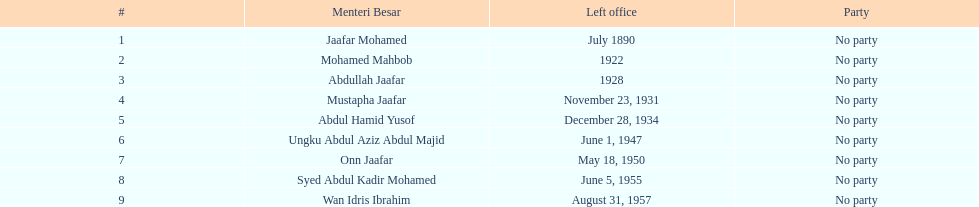Who is named below onn jaafar? Syed Abdul Kadir Mohamed. 